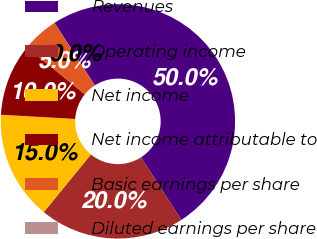<chart> <loc_0><loc_0><loc_500><loc_500><pie_chart><fcel>Revenues<fcel>Operating income<fcel>Net income<fcel>Net income attributable to<fcel>Basic earnings per share<fcel>Diluted earnings per share<nl><fcel>50.0%<fcel>20.0%<fcel>15.0%<fcel>10.0%<fcel>5.0%<fcel>0.0%<nl></chart> 